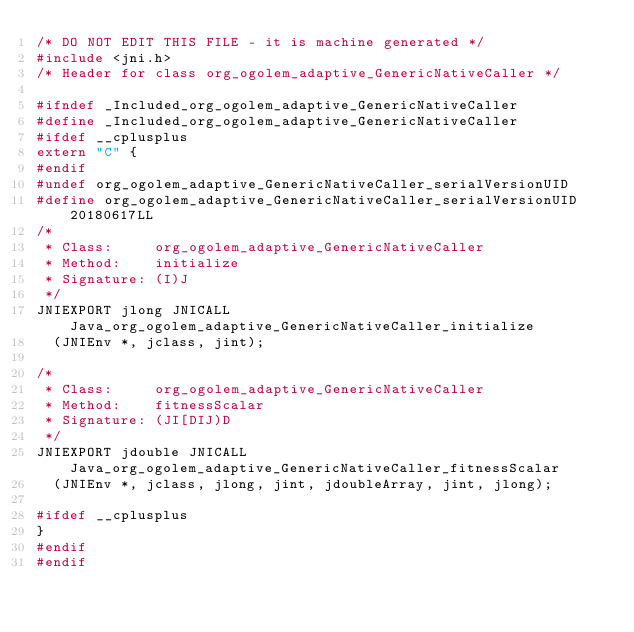Convert code to text. <code><loc_0><loc_0><loc_500><loc_500><_C_>/* DO NOT EDIT THIS FILE - it is machine generated */
#include <jni.h>
/* Header for class org_ogolem_adaptive_GenericNativeCaller */

#ifndef _Included_org_ogolem_adaptive_GenericNativeCaller
#define _Included_org_ogolem_adaptive_GenericNativeCaller
#ifdef __cplusplus
extern "C" {
#endif
#undef org_ogolem_adaptive_GenericNativeCaller_serialVersionUID
#define org_ogolem_adaptive_GenericNativeCaller_serialVersionUID 20180617LL
/*
 * Class:     org_ogolem_adaptive_GenericNativeCaller
 * Method:    initialize
 * Signature: (I)J
 */
JNIEXPORT jlong JNICALL Java_org_ogolem_adaptive_GenericNativeCaller_initialize
  (JNIEnv *, jclass, jint);

/*
 * Class:     org_ogolem_adaptive_GenericNativeCaller
 * Method:    fitnessScalar
 * Signature: (JI[DIJ)D
 */
JNIEXPORT jdouble JNICALL Java_org_ogolem_adaptive_GenericNativeCaller_fitnessScalar
  (JNIEnv *, jclass, jlong, jint, jdoubleArray, jint, jlong);

#ifdef __cplusplus
}
#endif
#endif
</code> 